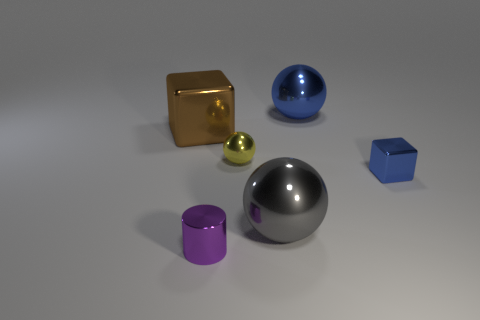Subtract all tiny yellow spheres. How many spheres are left? 2 Add 2 big red rubber objects. How many objects exist? 8 Subtract all blue blocks. How many blocks are left? 1 Subtract all blocks. How many objects are left? 4 Subtract 3 balls. How many balls are left? 0 Subtract all gray blocks. How many blue spheres are left? 1 Subtract all small yellow metallic spheres. Subtract all big brown shiny balls. How many objects are left? 5 Add 2 big blue things. How many big blue things are left? 3 Add 2 gray shiny balls. How many gray shiny balls exist? 3 Subtract 1 purple cylinders. How many objects are left? 5 